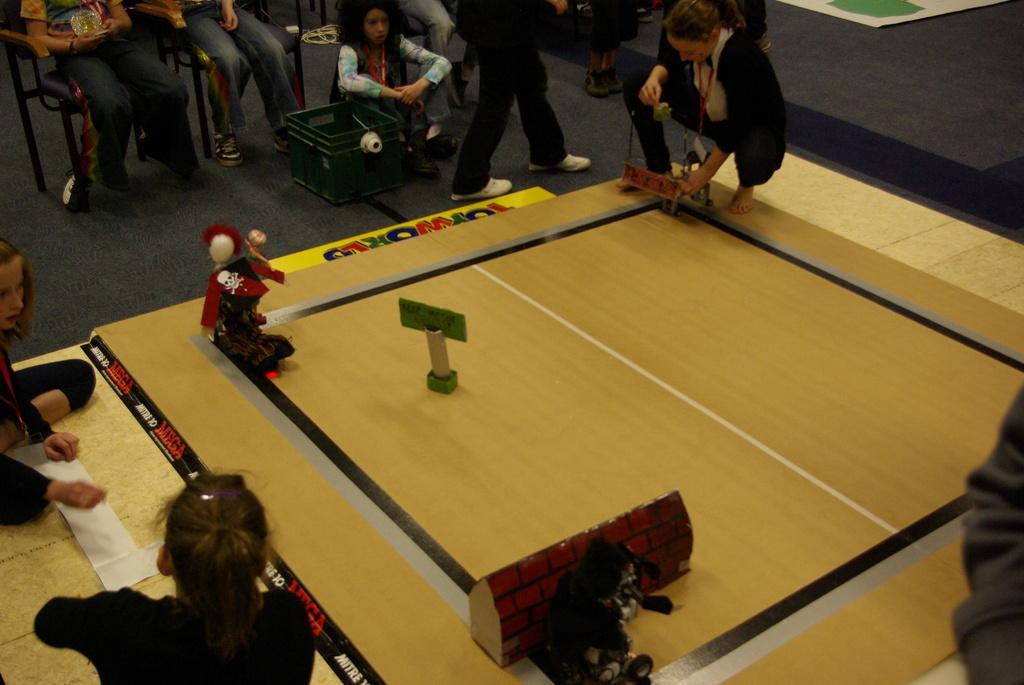Please provide a concise description of this image. In this image we can see a person's playing at a board. On the top of the image we can see a persons sitting. 